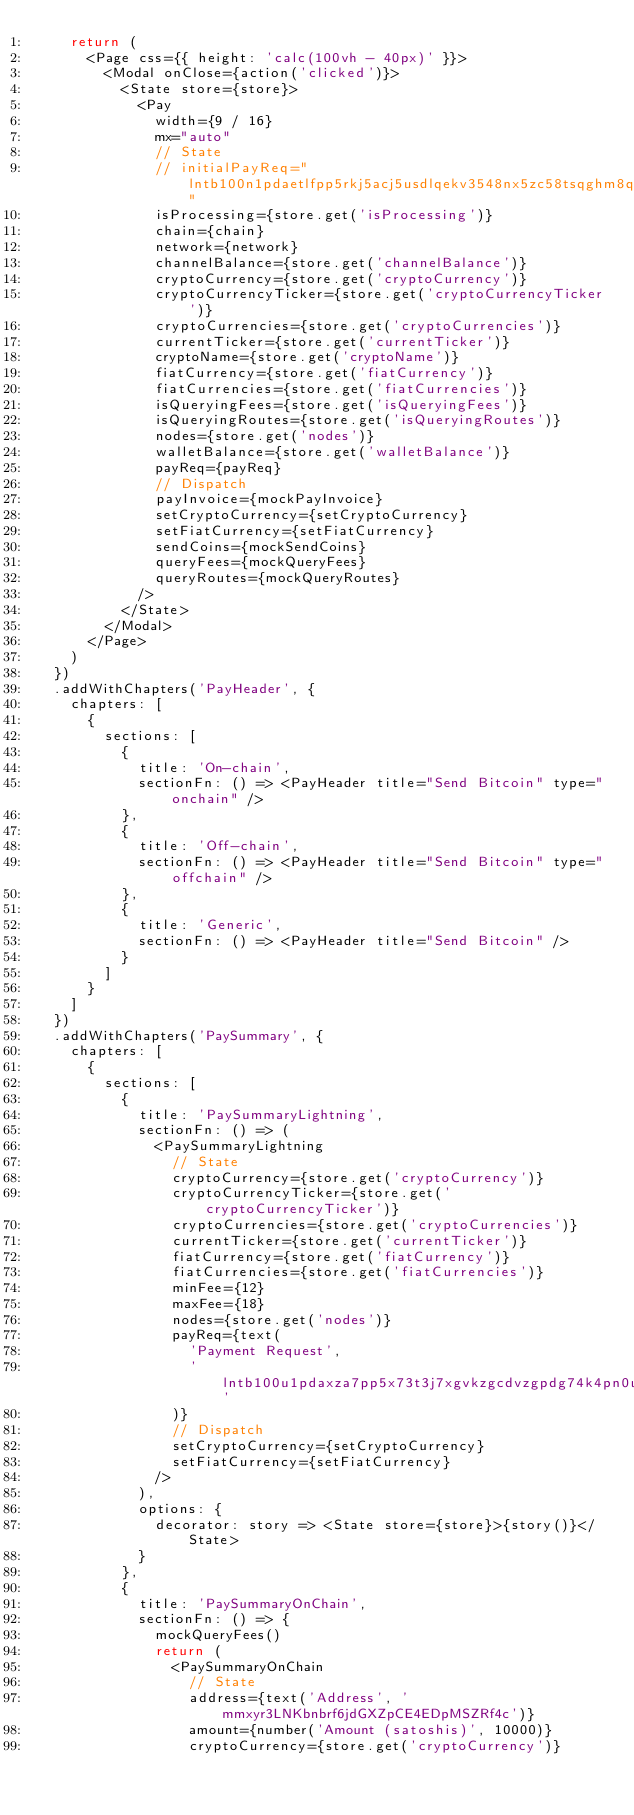<code> <loc_0><loc_0><loc_500><loc_500><_JavaScript_>    return (
      <Page css={{ height: 'calc(100vh - 40px)' }}>
        <Modal onClose={action('clicked')}>
          <State store={store}>
            <Pay
              width={9 / 16}
              mx="auto"
              // State
              // initialPayReq="lntb100n1pdaetlfpp5rkj5acj5usdlqekv3548nx5zc58tsqghm8qy6pdkrn3h37ep5aqsdqqcqzysxqyz5vq7vsxfsnak9yd0rf0zxpg9tukykxjqwef72apfwq2meg7wlz8zg0nxh3fmmc0ayv8ac5xhnlwlxajatqwnh3qwdx6uruyqn47enq9w6qplzqccc"
              isProcessing={store.get('isProcessing')}
              chain={chain}
              network={network}
              channelBalance={store.get('channelBalance')}
              cryptoCurrency={store.get('cryptoCurrency')}
              cryptoCurrencyTicker={store.get('cryptoCurrencyTicker')}
              cryptoCurrencies={store.get('cryptoCurrencies')}
              currentTicker={store.get('currentTicker')}
              cryptoName={store.get('cryptoName')}
              fiatCurrency={store.get('fiatCurrency')}
              fiatCurrencies={store.get('fiatCurrencies')}
              isQueryingFees={store.get('isQueryingFees')}
              isQueryingRoutes={store.get('isQueryingRoutes')}
              nodes={store.get('nodes')}
              walletBalance={store.get('walletBalance')}
              payReq={payReq}
              // Dispatch
              payInvoice={mockPayInvoice}
              setCryptoCurrency={setCryptoCurrency}
              setFiatCurrency={setFiatCurrency}
              sendCoins={mockSendCoins}
              queryFees={mockQueryFees}
              queryRoutes={mockQueryRoutes}
            />
          </State>
        </Modal>
      </Page>
    )
  })
  .addWithChapters('PayHeader', {
    chapters: [
      {
        sections: [
          {
            title: 'On-chain',
            sectionFn: () => <PayHeader title="Send Bitcoin" type="onchain" />
          },
          {
            title: 'Off-chain',
            sectionFn: () => <PayHeader title="Send Bitcoin" type="offchain" />
          },
          {
            title: 'Generic',
            sectionFn: () => <PayHeader title="Send Bitcoin" />
          }
        ]
      }
    ]
  })
  .addWithChapters('PaySummary', {
    chapters: [
      {
        sections: [
          {
            title: 'PaySummaryLightning',
            sectionFn: () => (
              <PaySummaryLightning
                // State
                cryptoCurrency={store.get('cryptoCurrency')}
                cryptoCurrencyTicker={store.get('cryptoCurrencyTicker')}
                cryptoCurrencies={store.get('cryptoCurrencies')}
                currentTicker={store.get('currentTicker')}
                fiatCurrency={store.get('fiatCurrency')}
                fiatCurrencies={store.get('fiatCurrencies')}
                minFee={12}
                maxFee={18}
                nodes={store.get('nodes')}
                payReq={text(
                  'Payment Request',
                  'lntb100u1pdaxza7pp5x73t3j7xgvkzgcdvzgpdg74k4pn0uhwuxlxu9qssytjn77x7zs4qdqqcqzysxqyz5vqd20eaq5uferzgzwasu5te3pla7gv8tzk8gcdxlj7lpkygvfdwndhwtl3ezn9ltjejl3hsp36ps3z3e5pp4rzp2hgqjqql80ec3hyzucq4d9axl'
                )}
                // Dispatch
                setCryptoCurrency={setCryptoCurrency}
                setFiatCurrency={setFiatCurrency}
              />
            ),
            options: {
              decorator: story => <State store={store}>{story()}</State>
            }
          },
          {
            title: 'PaySummaryOnChain',
            sectionFn: () => {
              mockQueryFees()
              return (
                <PaySummaryOnChain
                  // State
                  address={text('Address', 'mmxyr3LNKbnbrf6jdGXZpCE4EDpMSZRf4c')}
                  amount={number('Amount (satoshis)', 10000)}
                  cryptoCurrency={store.get('cryptoCurrency')}</code> 